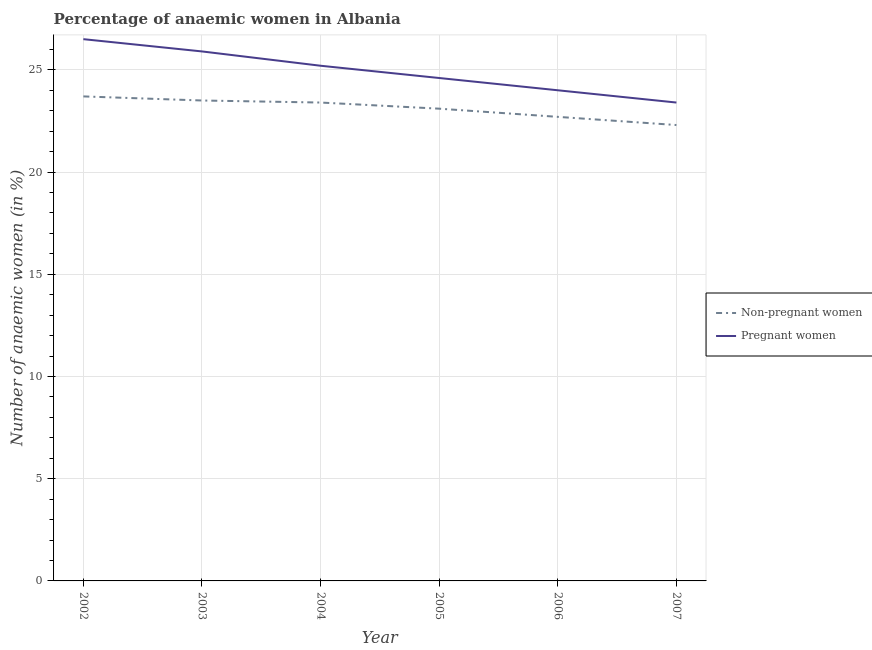How many different coloured lines are there?
Ensure brevity in your answer.  2. Does the line corresponding to percentage of pregnant anaemic women intersect with the line corresponding to percentage of non-pregnant anaemic women?
Provide a short and direct response. No. What is the percentage of non-pregnant anaemic women in 2005?
Your answer should be very brief. 23.1. Across all years, what is the maximum percentage of non-pregnant anaemic women?
Keep it short and to the point. 23.7. Across all years, what is the minimum percentage of non-pregnant anaemic women?
Offer a very short reply. 22.3. In which year was the percentage of pregnant anaemic women minimum?
Your answer should be very brief. 2007. What is the total percentage of pregnant anaemic women in the graph?
Your answer should be very brief. 149.6. What is the difference between the percentage of pregnant anaemic women in 2002 and that in 2005?
Provide a short and direct response. 1.9. What is the difference between the percentage of pregnant anaemic women in 2007 and the percentage of non-pregnant anaemic women in 2005?
Your answer should be very brief. 0.3. What is the average percentage of pregnant anaemic women per year?
Your answer should be compact. 24.93. In the year 2006, what is the difference between the percentage of non-pregnant anaemic women and percentage of pregnant anaemic women?
Offer a very short reply. -1.3. What is the ratio of the percentage of pregnant anaemic women in 2002 to that in 2007?
Keep it short and to the point. 1.13. Is the percentage of pregnant anaemic women in 2002 less than that in 2007?
Give a very brief answer. No. Is the difference between the percentage of non-pregnant anaemic women in 2002 and 2005 greater than the difference between the percentage of pregnant anaemic women in 2002 and 2005?
Offer a very short reply. No. What is the difference between the highest and the second highest percentage of non-pregnant anaemic women?
Your answer should be very brief. 0.2. What is the difference between the highest and the lowest percentage of non-pregnant anaemic women?
Offer a very short reply. 1.4. In how many years, is the percentage of pregnant anaemic women greater than the average percentage of pregnant anaemic women taken over all years?
Your answer should be very brief. 3. Does the percentage of non-pregnant anaemic women monotonically increase over the years?
Provide a succinct answer. No. Is the percentage of pregnant anaemic women strictly greater than the percentage of non-pregnant anaemic women over the years?
Make the answer very short. Yes. How many years are there in the graph?
Offer a terse response. 6. Does the graph contain any zero values?
Provide a succinct answer. No. Where does the legend appear in the graph?
Offer a terse response. Center right. How are the legend labels stacked?
Provide a succinct answer. Vertical. What is the title of the graph?
Give a very brief answer. Percentage of anaemic women in Albania. What is the label or title of the Y-axis?
Provide a short and direct response. Number of anaemic women (in %). What is the Number of anaemic women (in %) of Non-pregnant women in 2002?
Make the answer very short. 23.7. What is the Number of anaemic women (in %) in Pregnant women in 2003?
Keep it short and to the point. 25.9. What is the Number of anaemic women (in %) of Non-pregnant women in 2004?
Offer a terse response. 23.4. What is the Number of anaemic women (in %) in Pregnant women in 2004?
Provide a succinct answer. 25.2. What is the Number of anaemic women (in %) in Non-pregnant women in 2005?
Give a very brief answer. 23.1. What is the Number of anaemic women (in %) in Pregnant women in 2005?
Make the answer very short. 24.6. What is the Number of anaemic women (in %) of Non-pregnant women in 2006?
Keep it short and to the point. 22.7. What is the Number of anaemic women (in %) of Non-pregnant women in 2007?
Offer a very short reply. 22.3. What is the Number of anaemic women (in %) in Pregnant women in 2007?
Ensure brevity in your answer.  23.4. Across all years, what is the maximum Number of anaemic women (in %) of Non-pregnant women?
Your answer should be very brief. 23.7. Across all years, what is the maximum Number of anaemic women (in %) in Pregnant women?
Offer a terse response. 26.5. Across all years, what is the minimum Number of anaemic women (in %) in Non-pregnant women?
Keep it short and to the point. 22.3. Across all years, what is the minimum Number of anaemic women (in %) of Pregnant women?
Your response must be concise. 23.4. What is the total Number of anaemic women (in %) of Non-pregnant women in the graph?
Your answer should be very brief. 138.7. What is the total Number of anaemic women (in %) of Pregnant women in the graph?
Make the answer very short. 149.6. What is the difference between the Number of anaemic women (in %) in Non-pregnant women in 2002 and that in 2003?
Ensure brevity in your answer.  0.2. What is the difference between the Number of anaemic women (in %) in Pregnant women in 2002 and that in 2004?
Keep it short and to the point. 1.3. What is the difference between the Number of anaemic women (in %) of Non-pregnant women in 2002 and that in 2005?
Your answer should be compact. 0.6. What is the difference between the Number of anaemic women (in %) of Pregnant women in 2002 and that in 2005?
Your answer should be compact. 1.9. What is the difference between the Number of anaemic women (in %) of Non-pregnant women in 2002 and that in 2006?
Provide a succinct answer. 1. What is the difference between the Number of anaemic women (in %) of Non-pregnant women in 2002 and that in 2007?
Your answer should be very brief. 1.4. What is the difference between the Number of anaemic women (in %) of Pregnant women in 2003 and that in 2004?
Give a very brief answer. 0.7. What is the difference between the Number of anaemic women (in %) in Pregnant women in 2003 and that in 2005?
Offer a terse response. 1.3. What is the difference between the Number of anaemic women (in %) in Non-pregnant women in 2003 and that in 2006?
Offer a very short reply. 0.8. What is the difference between the Number of anaemic women (in %) of Pregnant women in 2003 and that in 2006?
Ensure brevity in your answer.  1.9. What is the difference between the Number of anaemic women (in %) in Non-pregnant women in 2004 and that in 2005?
Keep it short and to the point. 0.3. What is the difference between the Number of anaemic women (in %) of Non-pregnant women in 2004 and that in 2006?
Keep it short and to the point. 0.7. What is the difference between the Number of anaemic women (in %) of Pregnant women in 2004 and that in 2006?
Make the answer very short. 1.2. What is the difference between the Number of anaemic women (in %) of Non-pregnant women in 2004 and that in 2007?
Ensure brevity in your answer.  1.1. What is the difference between the Number of anaemic women (in %) of Non-pregnant women in 2005 and that in 2006?
Offer a terse response. 0.4. What is the difference between the Number of anaemic women (in %) in Non-pregnant women in 2002 and the Number of anaemic women (in %) in Pregnant women in 2003?
Offer a terse response. -2.2. What is the difference between the Number of anaemic women (in %) in Non-pregnant women in 2002 and the Number of anaemic women (in %) in Pregnant women in 2005?
Your answer should be compact. -0.9. What is the difference between the Number of anaemic women (in %) of Non-pregnant women in 2003 and the Number of anaemic women (in %) of Pregnant women in 2004?
Offer a terse response. -1.7. What is the difference between the Number of anaemic women (in %) in Non-pregnant women in 2003 and the Number of anaemic women (in %) in Pregnant women in 2006?
Offer a very short reply. -0.5. What is the difference between the Number of anaemic women (in %) of Non-pregnant women in 2003 and the Number of anaemic women (in %) of Pregnant women in 2007?
Keep it short and to the point. 0.1. What is the difference between the Number of anaemic women (in %) of Non-pregnant women in 2004 and the Number of anaemic women (in %) of Pregnant women in 2007?
Provide a succinct answer. 0. What is the difference between the Number of anaemic women (in %) of Non-pregnant women in 2005 and the Number of anaemic women (in %) of Pregnant women in 2007?
Provide a short and direct response. -0.3. What is the average Number of anaemic women (in %) in Non-pregnant women per year?
Your response must be concise. 23.12. What is the average Number of anaemic women (in %) in Pregnant women per year?
Your answer should be very brief. 24.93. In the year 2002, what is the difference between the Number of anaemic women (in %) in Non-pregnant women and Number of anaemic women (in %) in Pregnant women?
Your response must be concise. -2.8. In the year 2003, what is the difference between the Number of anaemic women (in %) of Non-pregnant women and Number of anaemic women (in %) of Pregnant women?
Ensure brevity in your answer.  -2.4. In the year 2004, what is the difference between the Number of anaemic women (in %) in Non-pregnant women and Number of anaemic women (in %) in Pregnant women?
Your answer should be compact. -1.8. In the year 2007, what is the difference between the Number of anaemic women (in %) in Non-pregnant women and Number of anaemic women (in %) in Pregnant women?
Your answer should be compact. -1.1. What is the ratio of the Number of anaemic women (in %) of Non-pregnant women in 2002 to that in 2003?
Make the answer very short. 1.01. What is the ratio of the Number of anaemic women (in %) of Pregnant women in 2002 to that in 2003?
Keep it short and to the point. 1.02. What is the ratio of the Number of anaemic women (in %) in Non-pregnant women in 2002 to that in 2004?
Ensure brevity in your answer.  1.01. What is the ratio of the Number of anaemic women (in %) of Pregnant women in 2002 to that in 2004?
Your answer should be compact. 1.05. What is the ratio of the Number of anaemic women (in %) of Non-pregnant women in 2002 to that in 2005?
Your response must be concise. 1.03. What is the ratio of the Number of anaemic women (in %) in Pregnant women in 2002 to that in 2005?
Offer a very short reply. 1.08. What is the ratio of the Number of anaemic women (in %) of Non-pregnant women in 2002 to that in 2006?
Keep it short and to the point. 1.04. What is the ratio of the Number of anaemic women (in %) in Pregnant women in 2002 to that in 2006?
Make the answer very short. 1.1. What is the ratio of the Number of anaemic women (in %) in Non-pregnant women in 2002 to that in 2007?
Ensure brevity in your answer.  1.06. What is the ratio of the Number of anaemic women (in %) in Pregnant women in 2002 to that in 2007?
Offer a terse response. 1.13. What is the ratio of the Number of anaemic women (in %) of Pregnant women in 2003 to that in 2004?
Your response must be concise. 1.03. What is the ratio of the Number of anaemic women (in %) in Non-pregnant women in 2003 to that in 2005?
Keep it short and to the point. 1.02. What is the ratio of the Number of anaemic women (in %) in Pregnant women in 2003 to that in 2005?
Offer a very short reply. 1.05. What is the ratio of the Number of anaemic women (in %) of Non-pregnant women in 2003 to that in 2006?
Give a very brief answer. 1.04. What is the ratio of the Number of anaemic women (in %) of Pregnant women in 2003 to that in 2006?
Your response must be concise. 1.08. What is the ratio of the Number of anaemic women (in %) in Non-pregnant women in 2003 to that in 2007?
Keep it short and to the point. 1.05. What is the ratio of the Number of anaemic women (in %) in Pregnant women in 2003 to that in 2007?
Ensure brevity in your answer.  1.11. What is the ratio of the Number of anaemic women (in %) in Pregnant women in 2004 to that in 2005?
Provide a succinct answer. 1.02. What is the ratio of the Number of anaemic women (in %) of Non-pregnant women in 2004 to that in 2006?
Give a very brief answer. 1.03. What is the ratio of the Number of anaemic women (in %) of Non-pregnant women in 2004 to that in 2007?
Your answer should be compact. 1.05. What is the ratio of the Number of anaemic women (in %) of Non-pregnant women in 2005 to that in 2006?
Give a very brief answer. 1.02. What is the ratio of the Number of anaemic women (in %) in Non-pregnant women in 2005 to that in 2007?
Offer a terse response. 1.04. What is the ratio of the Number of anaemic women (in %) of Pregnant women in 2005 to that in 2007?
Give a very brief answer. 1.05. What is the ratio of the Number of anaemic women (in %) in Non-pregnant women in 2006 to that in 2007?
Your answer should be very brief. 1.02. What is the ratio of the Number of anaemic women (in %) of Pregnant women in 2006 to that in 2007?
Ensure brevity in your answer.  1.03. What is the difference between the highest and the second highest Number of anaemic women (in %) in Non-pregnant women?
Offer a terse response. 0.2. What is the difference between the highest and the lowest Number of anaemic women (in %) of Non-pregnant women?
Your answer should be very brief. 1.4. What is the difference between the highest and the lowest Number of anaemic women (in %) in Pregnant women?
Keep it short and to the point. 3.1. 